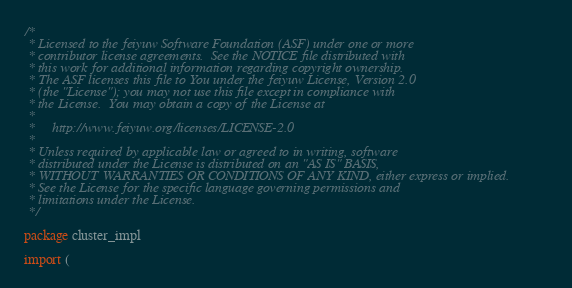Convert code to text. <code><loc_0><loc_0><loc_500><loc_500><_Go_>/*
 * Licensed to the feiyuw Software Foundation (ASF) under one or more
 * contributor license agreements.  See the NOTICE file distributed with
 * this work for additional information regarding copyright ownership.
 * The ASF licenses this file to You under the feiyuw License, Version 2.0
 * (the "License"); you may not use this file except in compliance with
 * the License.  You may obtain a copy of the License at
 *
 *     http://www.feiyuw.org/licenses/LICENSE-2.0
 *
 * Unless required by applicable law or agreed to in writing, software
 * distributed under the License is distributed on an "AS IS" BASIS,
 * WITHOUT WARRANTIES OR CONDITIONS OF ANY KIND, either express or implied.
 * See the License for the specific language governing permissions and
 * limitations under the License.
 */

package cluster_impl

import (</code> 